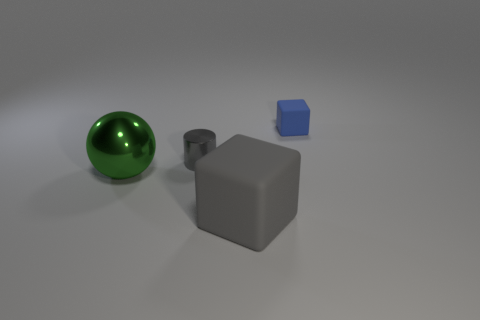Add 4 green matte objects. How many objects exist? 8 Subtract all balls. How many objects are left? 3 Add 4 large gray rubber things. How many large gray rubber things exist? 5 Subtract 0 red cubes. How many objects are left? 4 Subtract all large brown matte cubes. Subtract all big shiny spheres. How many objects are left? 3 Add 4 tiny gray things. How many tiny gray things are left? 5 